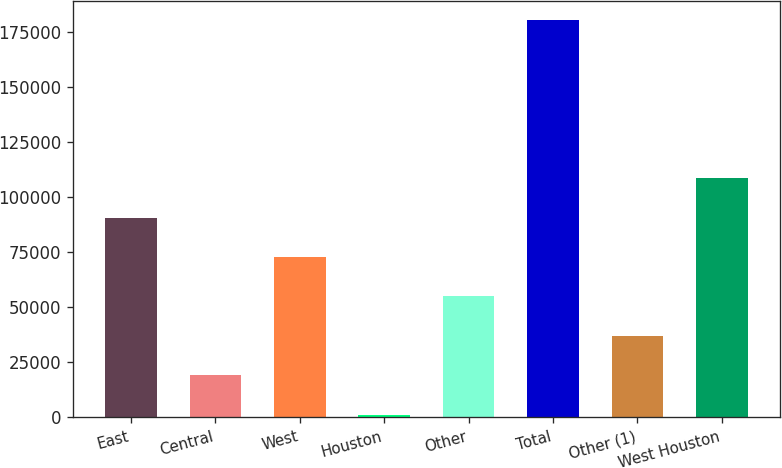<chart> <loc_0><loc_0><loc_500><loc_500><bar_chart><fcel>East<fcel>Central<fcel>West<fcel>Houston<fcel>Other<fcel>Total<fcel>Other (1)<fcel>West Houston<nl><fcel>90677.5<fcel>19028.3<fcel>72765.2<fcel>1116<fcel>54852.9<fcel>180239<fcel>36940.6<fcel>108590<nl></chart> 